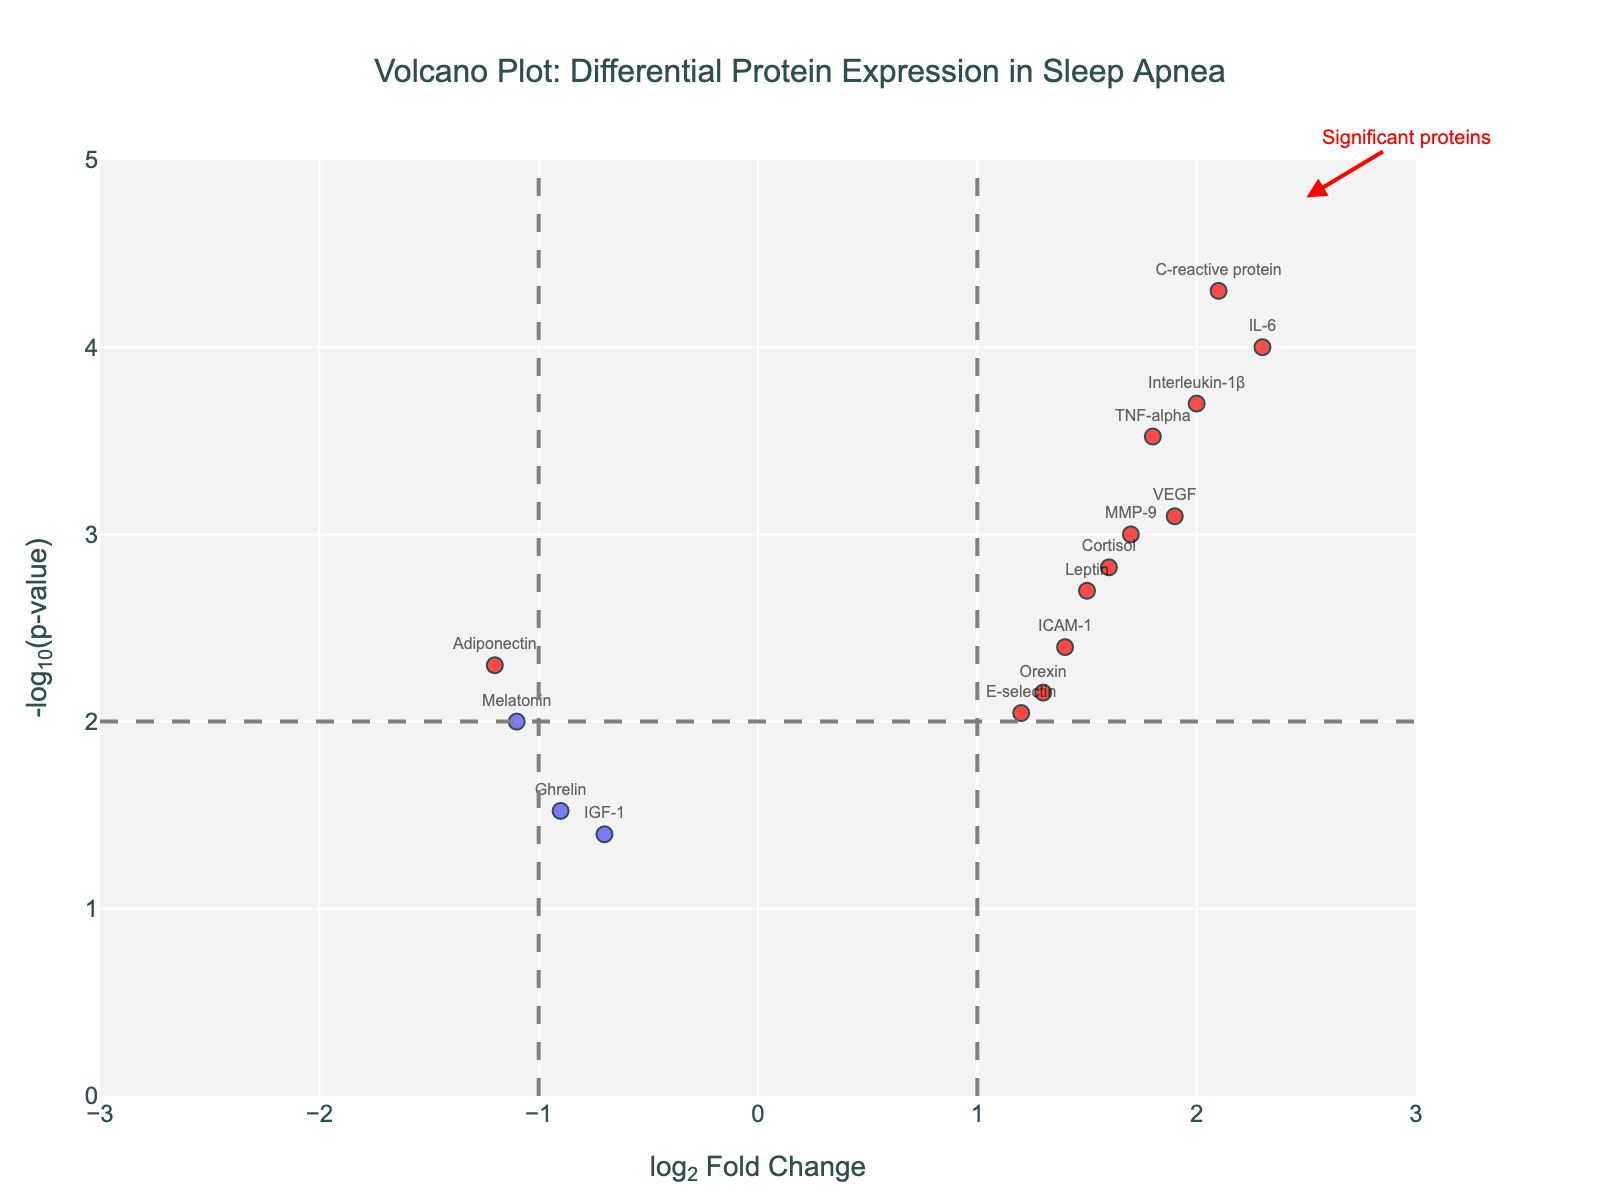How many proteins are plotted in the figure? Count the number of data points labeled with protein names in the plot.
Answer: 15 What is the title of the plot? Look at the text at the top of the figure for the main title.
Answer: Volcano Plot: Differential Protein Expression in Sleep Apnea Which protein is the most downregulated (has the most negative log2FC)? Identify the point with the lowest log2FC value (most negative) on the x-axis.
Answer: IGF-1 Which protein has the highest -log10(p-value)? Identify the point with the highest value on the y-axis.
Answer: C-reactive protein How many proteins are significantly differentially expressed? Count the number of data points colored in red, which indicate significance.
Answer: 9 What is the log2FC and p-value of Interleukin-1β? Refer to the labeled point for Interleukin-1β and hover over it or read the annotation text for its values.
Answer: log2FC: 2.0, p-value: 0.0002 Compare and contrast the expression patterns of IL-6 and Melatonin. Compare IL-6 and Melatonin by looking at their log2FC and -log10(p-value) positions. IL-6 has a high positive log2FC and low p-value (-log10(p-value) is high), while Melatonin has a negative log2FC and lower -log10(p-value).
Answer: IL-6: upregulated, Melatonin: downregulated What are the colors used to indicate significant and non-significant proteins? Look at the plot and identify colors used for significant and non-significant proteins.
Answer: Significant: red, Non-significant: blue How does the protein VEGF compare to the threshold lines? Identify VEGF on the plot and compare its log2FC and -log10(p-value) values to the threshold lines at log2FC = ±1 and -log10(p-value) = 2 (representing p-value = 0.01).
Answer: Above both thresholds What is the most upregulated protein? Identify the point with the highest log2FC value on the x-axis.
Answer: IL-6 